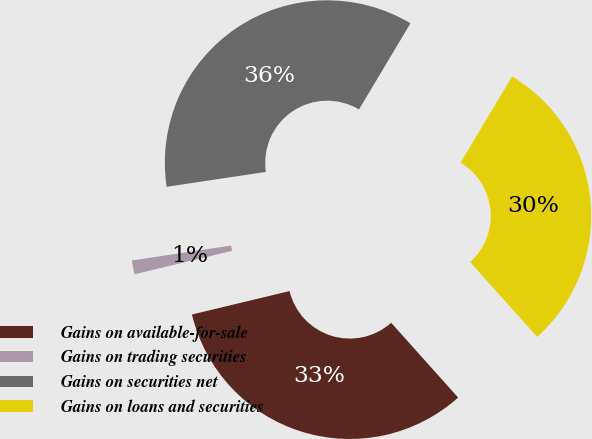Convert chart. <chart><loc_0><loc_0><loc_500><loc_500><pie_chart><fcel>Gains on available-for-sale<fcel>Gains on trading securities<fcel>Gains on securities net<fcel>Gains on loans and securities<nl><fcel>32.87%<fcel>1.38%<fcel>35.94%<fcel>29.81%<nl></chart> 